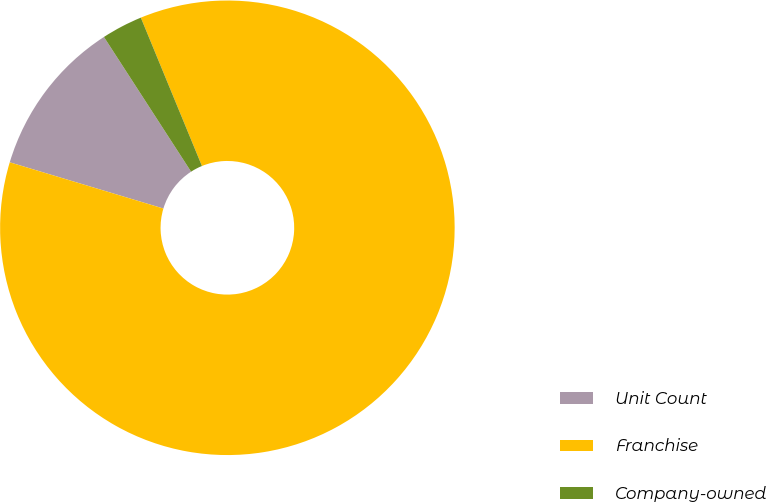<chart> <loc_0><loc_0><loc_500><loc_500><pie_chart><fcel>Unit Count<fcel>Franchise<fcel>Company-owned<nl><fcel>11.21%<fcel>85.87%<fcel>2.92%<nl></chart> 